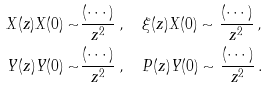Convert formula to latex. <formula><loc_0><loc_0><loc_500><loc_500>X ( z ) X ( 0 ) \sim & \frac { ( \cdots ) } { z ^ { 2 } } \, , \quad \xi ( z ) X ( 0 ) \sim \frac { ( \cdots ) } { z ^ { 2 } } \, , \\ Y ( z ) Y ( 0 ) \sim & \frac { ( \cdots ) } { z ^ { 2 } } \, , \quad P ( z ) Y ( 0 ) \sim \frac { ( \cdots ) } { z ^ { 2 } } \, .</formula> 